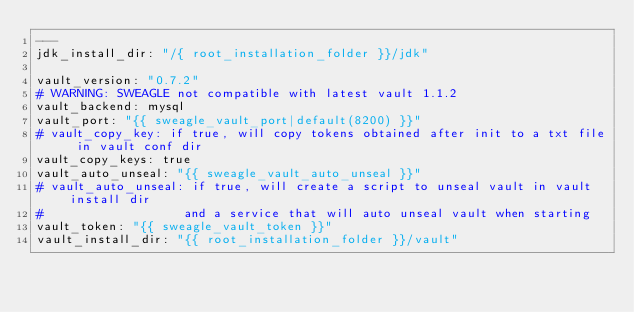<code> <loc_0><loc_0><loc_500><loc_500><_YAML_>---
jdk_install_dir: "/{ root_installation_folder }}/jdk"

vault_version: "0.7.2"
# WARNING: SWEAGLE not compatible with latest vault 1.1.2
vault_backend: mysql
vault_port: "{{ sweagle_vault_port|default(8200) }}"
# vault_copy_key: if true, will copy tokens obtained after init to a txt file in vault conf dir
vault_copy_keys: true
vault_auto_unseal: "{{ sweagle_vault_auto_unseal }}"
# vault_auto_unseal: if true, will create a script to unseal vault in vault install dir
#                   and a service that will auto unseal vault when starting
vault_token: "{{ sweagle_vault_token }}"
vault_install_dir: "{{ root_installation_folder }}/vault"
</code> 